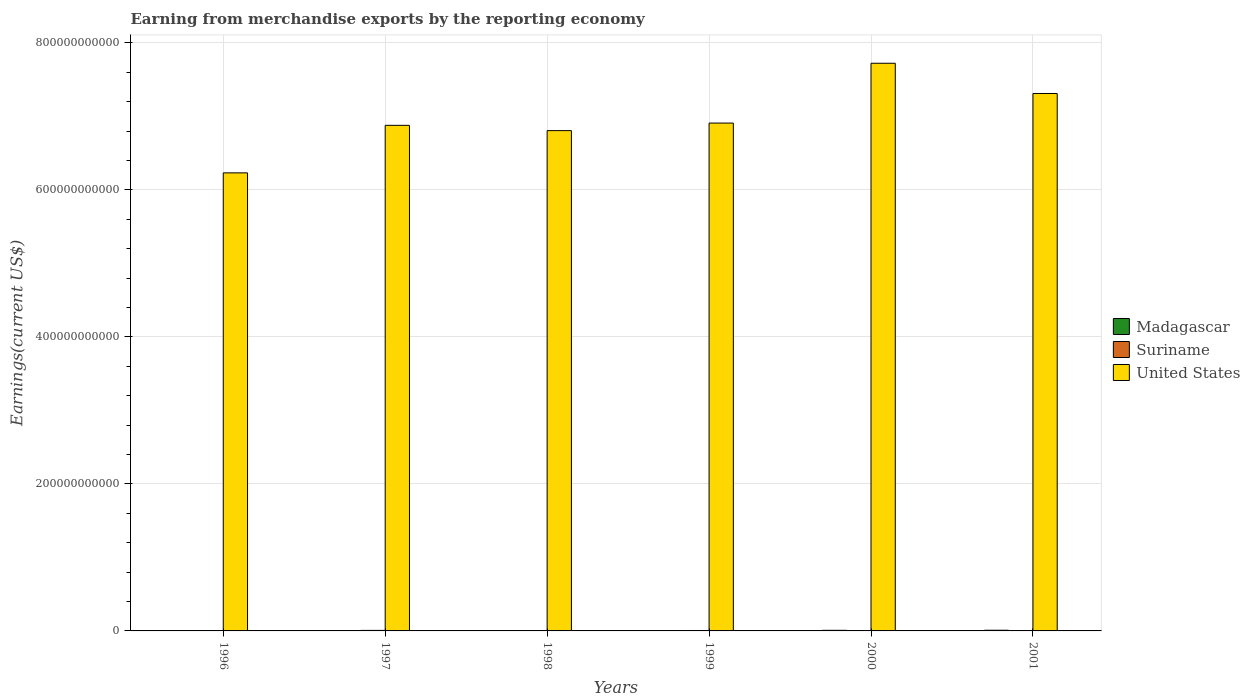How many different coloured bars are there?
Give a very brief answer. 3. How many groups of bars are there?
Offer a very short reply. 6. Are the number of bars per tick equal to the number of legend labels?
Your response must be concise. Yes. Are the number of bars on each tick of the X-axis equal?
Offer a very short reply. Yes. How many bars are there on the 5th tick from the left?
Provide a succinct answer. 3. How many bars are there on the 5th tick from the right?
Your answer should be compact. 3. What is the label of the 5th group of bars from the left?
Provide a short and direct response. 2000. What is the amount earned from merchandise exports in Suriname in 1997?
Ensure brevity in your answer.  7.01e+08. Across all years, what is the maximum amount earned from merchandise exports in Suriname?
Offer a very short reply. 7.01e+08. Across all years, what is the minimum amount earned from merchandise exports in Suriname?
Ensure brevity in your answer.  1.71e+08. In which year was the amount earned from merchandise exports in Suriname minimum?
Offer a terse response. 2001. What is the total amount earned from merchandise exports in United States in the graph?
Offer a terse response. 4.19e+12. What is the difference between the amount earned from merchandise exports in United States in 1998 and that in 1999?
Provide a succinct answer. -1.03e+1. What is the difference between the amount earned from merchandise exports in Suriname in 2001 and the amount earned from merchandise exports in United States in 1999?
Your answer should be very brief. -6.91e+11. What is the average amount earned from merchandise exports in Suriname per year?
Keep it short and to the point. 4.72e+08. In the year 2001, what is the difference between the amount earned from merchandise exports in Madagascar and amount earned from merchandise exports in United States?
Provide a short and direct response. -7.30e+11. In how many years, is the amount earned from merchandise exports in Madagascar greater than 40000000000 US$?
Offer a very short reply. 0. What is the ratio of the amount earned from merchandise exports in Suriname in 1996 to that in 1997?
Keep it short and to the point. 0.63. Is the amount earned from merchandise exports in Madagascar in 1997 less than that in 2000?
Your answer should be very brief. Yes. What is the difference between the highest and the second highest amount earned from merchandise exports in United States?
Keep it short and to the point. 4.11e+1. What is the difference between the highest and the lowest amount earned from merchandise exports in United States?
Provide a short and direct response. 1.49e+11. Is the sum of the amount earned from merchandise exports in United States in 1997 and 2000 greater than the maximum amount earned from merchandise exports in Suriname across all years?
Keep it short and to the point. Yes. What does the 2nd bar from the left in 1999 represents?
Provide a short and direct response. Suriname. What does the 3rd bar from the right in 2000 represents?
Give a very brief answer. Madagascar. Is it the case that in every year, the sum of the amount earned from merchandise exports in United States and amount earned from merchandise exports in Madagascar is greater than the amount earned from merchandise exports in Suriname?
Provide a short and direct response. Yes. Are all the bars in the graph horizontal?
Ensure brevity in your answer.  No. How many years are there in the graph?
Your answer should be compact. 6. What is the difference between two consecutive major ticks on the Y-axis?
Your response must be concise. 2.00e+11. Does the graph contain grids?
Ensure brevity in your answer.  Yes. Where does the legend appear in the graph?
Make the answer very short. Center right. What is the title of the graph?
Ensure brevity in your answer.  Earning from merchandise exports by the reporting economy. Does "El Salvador" appear as one of the legend labels in the graph?
Offer a very short reply. No. What is the label or title of the X-axis?
Your answer should be very brief. Years. What is the label or title of the Y-axis?
Offer a very short reply. Earnings(current US$). What is the Earnings(current US$) of Madagascar in 1996?
Your response must be concise. 2.99e+08. What is the Earnings(current US$) in Suriname in 1996?
Provide a short and direct response. 4.39e+08. What is the Earnings(current US$) of United States in 1996?
Give a very brief answer. 6.23e+11. What is the Earnings(current US$) in Madagascar in 1997?
Your answer should be compact. 2.24e+08. What is the Earnings(current US$) in Suriname in 1997?
Give a very brief answer. 7.01e+08. What is the Earnings(current US$) of United States in 1997?
Offer a very short reply. 6.88e+11. What is the Earnings(current US$) in Madagascar in 1998?
Your answer should be very brief. 2.34e+08. What is the Earnings(current US$) of Suriname in 1998?
Keep it short and to the point. 4.36e+08. What is the Earnings(current US$) in United States in 1998?
Your response must be concise. 6.81e+11. What is the Earnings(current US$) of Madagascar in 1999?
Provide a succinct answer. 2.20e+08. What is the Earnings(current US$) of Suriname in 1999?
Offer a terse response. 5.87e+08. What is the Earnings(current US$) in United States in 1999?
Ensure brevity in your answer.  6.91e+11. What is the Earnings(current US$) of Madagascar in 2000?
Make the answer very short. 8.24e+08. What is the Earnings(current US$) in Suriname in 2000?
Provide a succinct answer. 4.98e+08. What is the Earnings(current US$) of United States in 2000?
Your answer should be very brief. 7.72e+11. What is the Earnings(current US$) in Madagascar in 2001?
Provide a succinct answer. 9.26e+08. What is the Earnings(current US$) of Suriname in 2001?
Ensure brevity in your answer.  1.71e+08. What is the Earnings(current US$) of United States in 2001?
Your response must be concise. 7.31e+11. Across all years, what is the maximum Earnings(current US$) in Madagascar?
Your answer should be very brief. 9.26e+08. Across all years, what is the maximum Earnings(current US$) of Suriname?
Make the answer very short. 7.01e+08. Across all years, what is the maximum Earnings(current US$) in United States?
Your answer should be very brief. 7.72e+11. Across all years, what is the minimum Earnings(current US$) in Madagascar?
Make the answer very short. 2.20e+08. Across all years, what is the minimum Earnings(current US$) in Suriname?
Offer a very short reply. 1.71e+08. Across all years, what is the minimum Earnings(current US$) of United States?
Keep it short and to the point. 6.23e+11. What is the total Earnings(current US$) in Madagascar in the graph?
Ensure brevity in your answer.  2.73e+09. What is the total Earnings(current US$) of Suriname in the graph?
Your answer should be very brief. 2.83e+09. What is the total Earnings(current US$) of United States in the graph?
Your answer should be very brief. 4.19e+12. What is the difference between the Earnings(current US$) in Madagascar in 1996 and that in 1997?
Offer a terse response. 7.57e+07. What is the difference between the Earnings(current US$) in Suriname in 1996 and that in 1997?
Provide a short and direct response. -2.62e+08. What is the difference between the Earnings(current US$) in United States in 1996 and that in 1997?
Keep it short and to the point. -6.46e+1. What is the difference between the Earnings(current US$) in Madagascar in 1996 and that in 1998?
Offer a very short reply. 6.54e+07. What is the difference between the Earnings(current US$) in Suriname in 1996 and that in 1998?
Give a very brief answer. 2.89e+06. What is the difference between the Earnings(current US$) in United States in 1996 and that in 1998?
Make the answer very short. -5.75e+1. What is the difference between the Earnings(current US$) in Madagascar in 1996 and that in 1999?
Offer a very short reply. 7.90e+07. What is the difference between the Earnings(current US$) in Suriname in 1996 and that in 1999?
Offer a very short reply. -1.48e+08. What is the difference between the Earnings(current US$) in United States in 1996 and that in 1999?
Your answer should be compact. -6.77e+1. What is the difference between the Earnings(current US$) in Madagascar in 1996 and that in 2000?
Offer a terse response. -5.25e+08. What is the difference between the Earnings(current US$) of Suriname in 1996 and that in 2000?
Your answer should be compact. -5.95e+07. What is the difference between the Earnings(current US$) in United States in 1996 and that in 2000?
Give a very brief answer. -1.49e+11. What is the difference between the Earnings(current US$) of Madagascar in 1996 and that in 2001?
Give a very brief answer. -6.26e+08. What is the difference between the Earnings(current US$) in Suriname in 1996 and that in 2001?
Your response must be concise. 2.68e+08. What is the difference between the Earnings(current US$) of United States in 1996 and that in 2001?
Provide a succinct answer. -1.08e+11. What is the difference between the Earnings(current US$) of Madagascar in 1997 and that in 1998?
Provide a short and direct response. -1.03e+07. What is the difference between the Earnings(current US$) in Suriname in 1997 and that in 1998?
Provide a short and direct response. 2.65e+08. What is the difference between the Earnings(current US$) of United States in 1997 and that in 1998?
Your answer should be very brief. 7.19e+09. What is the difference between the Earnings(current US$) in Madagascar in 1997 and that in 1999?
Offer a terse response. 3.26e+06. What is the difference between the Earnings(current US$) of Suriname in 1997 and that in 1999?
Provide a succinct answer. 1.15e+08. What is the difference between the Earnings(current US$) in United States in 1997 and that in 1999?
Provide a short and direct response. -3.08e+09. What is the difference between the Earnings(current US$) in Madagascar in 1997 and that in 2000?
Keep it short and to the point. -6.00e+08. What is the difference between the Earnings(current US$) in Suriname in 1997 and that in 2000?
Offer a very short reply. 2.03e+08. What is the difference between the Earnings(current US$) in United States in 1997 and that in 2000?
Your answer should be very brief. -8.44e+1. What is the difference between the Earnings(current US$) of Madagascar in 1997 and that in 2001?
Provide a succinct answer. -7.02e+08. What is the difference between the Earnings(current US$) of Suriname in 1997 and that in 2001?
Keep it short and to the point. 5.30e+08. What is the difference between the Earnings(current US$) of United States in 1997 and that in 2001?
Provide a succinct answer. -4.33e+1. What is the difference between the Earnings(current US$) of Madagascar in 1998 and that in 1999?
Keep it short and to the point. 1.36e+07. What is the difference between the Earnings(current US$) of Suriname in 1998 and that in 1999?
Your answer should be very brief. -1.51e+08. What is the difference between the Earnings(current US$) of United States in 1998 and that in 1999?
Give a very brief answer. -1.03e+1. What is the difference between the Earnings(current US$) in Madagascar in 1998 and that in 2000?
Make the answer very short. -5.90e+08. What is the difference between the Earnings(current US$) of Suriname in 1998 and that in 2000?
Your answer should be very brief. -6.24e+07. What is the difference between the Earnings(current US$) in United States in 1998 and that in 2000?
Provide a short and direct response. -9.16e+1. What is the difference between the Earnings(current US$) in Madagascar in 1998 and that in 2001?
Give a very brief answer. -6.92e+08. What is the difference between the Earnings(current US$) of Suriname in 1998 and that in 2001?
Your answer should be compact. 2.65e+08. What is the difference between the Earnings(current US$) in United States in 1998 and that in 2001?
Your answer should be compact. -5.05e+1. What is the difference between the Earnings(current US$) in Madagascar in 1999 and that in 2000?
Your answer should be compact. -6.04e+08. What is the difference between the Earnings(current US$) in Suriname in 1999 and that in 2000?
Give a very brief answer. 8.82e+07. What is the difference between the Earnings(current US$) in United States in 1999 and that in 2000?
Give a very brief answer. -8.14e+1. What is the difference between the Earnings(current US$) of Madagascar in 1999 and that in 2001?
Offer a very short reply. -7.05e+08. What is the difference between the Earnings(current US$) in Suriname in 1999 and that in 2001?
Your response must be concise. 4.16e+08. What is the difference between the Earnings(current US$) of United States in 1999 and that in 2001?
Offer a very short reply. -4.02e+1. What is the difference between the Earnings(current US$) of Madagascar in 2000 and that in 2001?
Keep it short and to the point. -1.02e+08. What is the difference between the Earnings(current US$) of Suriname in 2000 and that in 2001?
Provide a succinct answer. 3.27e+08. What is the difference between the Earnings(current US$) of United States in 2000 and that in 2001?
Ensure brevity in your answer.  4.11e+1. What is the difference between the Earnings(current US$) of Madagascar in 1996 and the Earnings(current US$) of Suriname in 1997?
Offer a very short reply. -4.02e+08. What is the difference between the Earnings(current US$) of Madagascar in 1996 and the Earnings(current US$) of United States in 1997?
Offer a terse response. -6.87e+11. What is the difference between the Earnings(current US$) in Suriname in 1996 and the Earnings(current US$) in United States in 1997?
Provide a short and direct response. -6.87e+11. What is the difference between the Earnings(current US$) in Madagascar in 1996 and the Earnings(current US$) in Suriname in 1998?
Your answer should be compact. -1.37e+08. What is the difference between the Earnings(current US$) of Madagascar in 1996 and the Earnings(current US$) of United States in 1998?
Make the answer very short. -6.80e+11. What is the difference between the Earnings(current US$) in Suriname in 1996 and the Earnings(current US$) in United States in 1998?
Provide a short and direct response. -6.80e+11. What is the difference between the Earnings(current US$) in Madagascar in 1996 and the Earnings(current US$) in Suriname in 1999?
Give a very brief answer. -2.87e+08. What is the difference between the Earnings(current US$) in Madagascar in 1996 and the Earnings(current US$) in United States in 1999?
Make the answer very short. -6.90e+11. What is the difference between the Earnings(current US$) in Suriname in 1996 and the Earnings(current US$) in United States in 1999?
Offer a very short reply. -6.90e+11. What is the difference between the Earnings(current US$) in Madagascar in 1996 and the Earnings(current US$) in Suriname in 2000?
Offer a very short reply. -1.99e+08. What is the difference between the Earnings(current US$) in Madagascar in 1996 and the Earnings(current US$) in United States in 2000?
Offer a very short reply. -7.72e+11. What is the difference between the Earnings(current US$) of Suriname in 1996 and the Earnings(current US$) of United States in 2000?
Ensure brevity in your answer.  -7.72e+11. What is the difference between the Earnings(current US$) of Madagascar in 1996 and the Earnings(current US$) of Suriname in 2001?
Ensure brevity in your answer.  1.28e+08. What is the difference between the Earnings(current US$) in Madagascar in 1996 and the Earnings(current US$) in United States in 2001?
Make the answer very short. -7.31e+11. What is the difference between the Earnings(current US$) in Suriname in 1996 and the Earnings(current US$) in United States in 2001?
Keep it short and to the point. -7.31e+11. What is the difference between the Earnings(current US$) of Madagascar in 1997 and the Earnings(current US$) of Suriname in 1998?
Your response must be concise. -2.12e+08. What is the difference between the Earnings(current US$) of Madagascar in 1997 and the Earnings(current US$) of United States in 1998?
Keep it short and to the point. -6.80e+11. What is the difference between the Earnings(current US$) of Suriname in 1997 and the Earnings(current US$) of United States in 1998?
Offer a very short reply. -6.80e+11. What is the difference between the Earnings(current US$) in Madagascar in 1997 and the Earnings(current US$) in Suriname in 1999?
Provide a short and direct response. -3.63e+08. What is the difference between the Earnings(current US$) in Madagascar in 1997 and the Earnings(current US$) in United States in 1999?
Offer a very short reply. -6.91e+11. What is the difference between the Earnings(current US$) in Suriname in 1997 and the Earnings(current US$) in United States in 1999?
Provide a succinct answer. -6.90e+11. What is the difference between the Earnings(current US$) of Madagascar in 1997 and the Earnings(current US$) of Suriname in 2000?
Offer a very short reply. -2.75e+08. What is the difference between the Earnings(current US$) of Madagascar in 1997 and the Earnings(current US$) of United States in 2000?
Keep it short and to the point. -7.72e+11. What is the difference between the Earnings(current US$) in Suriname in 1997 and the Earnings(current US$) in United States in 2000?
Ensure brevity in your answer.  -7.71e+11. What is the difference between the Earnings(current US$) in Madagascar in 1997 and the Earnings(current US$) in Suriname in 2001?
Make the answer very short. 5.26e+07. What is the difference between the Earnings(current US$) of Madagascar in 1997 and the Earnings(current US$) of United States in 2001?
Make the answer very short. -7.31e+11. What is the difference between the Earnings(current US$) of Suriname in 1997 and the Earnings(current US$) of United States in 2001?
Offer a terse response. -7.30e+11. What is the difference between the Earnings(current US$) in Madagascar in 1998 and the Earnings(current US$) in Suriname in 1999?
Your answer should be very brief. -3.53e+08. What is the difference between the Earnings(current US$) in Madagascar in 1998 and the Earnings(current US$) in United States in 1999?
Keep it short and to the point. -6.91e+11. What is the difference between the Earnings(current US$) of Suriname in 1998 and the Earnings(current US$) of United States in 1999?
Your answer should be very brief. -6.90e+11. What is the difference between the Earnings(current US$) of Madagascar in 1998 and the Earnings(current US$) of Suriname in 2000?
Provide a succinct answer. -2.64e+08. What is the difference between the Earnings(current US$) of Madagascar in 1998 and the Earnings(current US$) of United States in 2000?
Provide a succinct answer. -7.72e+11. What is the difference between the Earnings(current US$) of Suriname in 1998 and the Earnings(current US$) of United States in 2000?
Provide a succinct answer. -7.72e+11. What is the difference between the Earnings(current US$) in Madagascar in 1998 and the Earnings(current US$) in Suriname in 2001?
Make the answer very short. 6.30e+07. What is the difference between the Earnings(current US$) in Madagascar in 1998 and the Earnings(current US$) in United States in 2001?
Your response must be concise. -7.31e+11. What is the difference between the Earnings(current US$) in Suriname in 1998 and the Earnings(current US$) in United States in 2001?
Your answer should be compact. -7.31e+11. What is the difference between the Earnings(current US$) in Madagascar in 1999 and the Earnings(current US$) in Suriname in 2000?
Ensure brevity in your answer.  -2.78e+08. What is the difference between the Earnings(current US$) of Madagascar in 1999 and the Earnings(current US$) of United States in 2000?
Your response must be concise. -7.72e+11. What is the difference between the Earnings(current US$) in Suriname in 1999 and the Earnings(current US$) in United States in 2000?
Provide a short and direct response. -7.72e+11. What is the difference between the Earnings(current US$) in Madagascar in 1999 and the Earnings(current US$) in Suriname in 2001?
Provide a short and direct response. 4.94e+07. What is the difference between the Earnings(current US$) of Madagascar in 1999 and the Earnings(current US$) of United States in 2001?
Ensure brevity in your answer.  -7.31e+11. What is the difference between the Earnings(current US$) in Suriname in 1999 and the Earnings(current US$) in United States in 2001?
Keep it short and to the point. -7.30e+11. What is the difference between the Earnings(current US$) of Madagascar in 2000 and the Earnings(current US$) of Suriname in 2001?
Keep it short and to the point. 6.53e+08. What is the difference between the Earnings(current US$) in Madagascar in 2000 and the Earnings(current US$) in United States in 2001?
Offer a terse response. -7.30e+11. What is the difference between the Earnings(current US$) of Suriname in 2000 and the Earnings(current US$) of United States in 2001?
Offer a very short reply. -7.31e+11. What is the average Earnings(current US$) in Madagascar per year?
Make the answer very short. 4.55e+08. What is the average Earnings(current US$) of Suriname per year?
Your response must be concise. 4.72e+08. What is the average Earnings(current US$) of United States per year?
Provide a short and direct response. 6.98e+11. In the year 1996, what is the difference between the Earnings(current US$) of Madagascar and Earnings(current US$) of Suriname?
Keep it short and to the point. -1.39e+08. In the year 1996, what is the difference between the Earnings(current US$) in Madagascar and Earnings(current US$) in United States?
Give a very brief answer. -6.23e+11. In the year 1996, what is the difference between the Earnings(current US$) in Suriname and Earnings(current US$) in United States?
Your answer should be compact. -6.23e+11. In the year 1997, what is the difference between the Earnings(current US$) in Madagascar and Earnings(current US$) in Suriname?
Provide a short and direct response. -4.78e+08. In the year 1997, what is the difference between the Earnings(current US$) of Madagascar and Earnings(current US$) of United States?
Provide a succinct answer. -6.87e+11. In the year 1997, what is the difference between the Earnings(current US$) in Suriname and Earnings(current US$) in United States?
Offer a terse response. -6.87e+11. In the year 1998, what is the difference between the Earnings(current US$) of Madagascar and Earnings(current US$) of Suriname?
Provide a short and direct response. -2.02e+08. In the year 1998, what is the difference between the Earnings(current US$) of Madagascar and Earnings(current US$) of United States?
Your answer should be compact. -6.80e+11. In the year 1998, what is the difference between the Earnings(current US$) of Suriname and Earnings(current US$) of United States?
Offer a terse response. -6.80e+11. In the year 1999, what is the difference between the Earnings(current US$) in Madagascar and Earnings(current US$) in Suriname?
Your answer should be very brief. -3.66e+08. In the year 1999, what is the difference between the Earnings(current US$) in Madagascar and Earnings(current US$) in United States?
Offer a very short reply. -6.91e+11. In the year 1999, what is the difference between the Earnings(current US$) of Suriname and Earnings(current US$) of United States?
Ensure brevity in your answer.  -6.90e+11. In the year 2000, what is the difference between the Earnings(current US$) of Madagascar and Earnings(current US$) of Suriname?
Your answer should be very brief. 3.26e+08. In the year 2000, what is the difference between the Earnings(current US$) in Madagascar and Earnings(current US$) in United States?
Give a very brief answer. -7.71e+11. In the year 2000, what is the difference between the Earnings(current US$) of Suriname and Earnings(current US$) of United States?
Offer a very short reply. -7.72e+11. In the year 2001, what is the difference between the Earnings(current US$) in Madagascar and Earnings(current US$) in Suriname?
Offer a very short reply. 7.55e+08. In the year 2001, what is the difference between the Earnings(current US$) in Madagascar and Earnings(current US$) in United States?
Offer a terse response. -7.30e+11. In the year 2001, what is the difference between the Earnings(current US$) in Suriname and Earnings(current US$) in United States?
Your answer should be compact. -7.31e+11. What is the ratio of the Earnings(current US$) in Madagascar in 1996 to that in 1997?
Your response must be concise. 1.34. What is the ratio of the Earnings(current US$) in Suriname in 1996 to that in 1997?
Provide a short and direct response. 0.63. What is the ratio of the Earnings(current US$) in United States in 1996 to that in 1997?
Your answer should be compact. 0.91. What is the ratio of the Earnings(current US$) of Madagascar in 1996 to that in 1998?
Provide a short and direct response. 1.28. What is the ratio of the Earnings(current US$) in Suriname in 1996 to that in 1998?
Your response must be concise. 1.01. What is the ratio of the Earnings(current US$) in United States in 1996 to that in 1998?
Provide a succinct answer. 0.92. What is the ratio of the Earnings(current US$) in Madagascar in 1996 to that in 1999?
Keep it short and to the point. 1.36. What is the ratio of the Earnings(current US$) of Suriname in 1996 to that in 1999?
Provide a short and direct response. 0.75. What is the ratio of the Earnings(current US$) in United States in 1996 to that in 1999?
Ensure brevity in your answer.  0.9. What is the ratio of the Earnings(current US$) in Madagascar in 1996 to that in 2000?
Ensure brevity in your answer.  0.36. What is the ratio of the Earnings(current US$) in Suriname in 1996 to that in 2000?
Offer a terse response. 0.88. What is the ratio of the Earnings(current US$) of United States in 1996 to that in 2000?
Your response must be concise. 0.81. What is the ratio of the Earnings(current US$) of Madagascar in 1996 to that in 2001?
Your response must be concise. 0.32. What is the ratio of the Earnings(current US$) of Suriname in 1996 to that in 2001?
Your answer should be compact. 2.56. What is the ratio of the Earnings(current US$) of United States in 1996 to that in 2001?
Provide a succinct answer. 0.85. What is the ratio of the Earnings(current US$) in Madagascar in 1997 to that in 1998?
Ensure brevity in your answer.  0.96. What is the ratio of the Earnings(current US$) of Suriname in 1997 to that in 1998?
Provide a succinct answer. 1.61. What is the ratio of the Earnings(current US$) of United States in 1997 to that in 1998?
Provide a succinct answer. 1.01. What is the ratio of the Earnings(current US$) of Madagascar in 1997 to that in 1999?
Give a very brief answer. 1.01. What is the ratio of the Earnings(current US$) in Suriname in 1997 to that in 1999?
Your response must be concise. 1.2. What is the ratio of the Earnings(current US$) of Madagascar in 1997 to that in 2000?
Provide a succinct answer. 0.27. What is the ratio of the Earnings(current US$) of Suriname in 1997 to that in 2000?
Your answer should be compact. 1.41. What is the ratio of the Earnings(current US$) in United States in 1997 to that in 2000?
Make the answer very short. 0.89. What is the ratio of the Earnings(current US$) of Madagascar in 1997 to that in 2001?
Offer a very short reply. 0.24. What is the ratio of the Earnings(current US$) of Suriname in 1997 to that in 2001?
Give a very brief answer. 4.1. What is the ratio of the Earnings(current US$) of United States in 1997 to that in 2001?
Give a very brief answer. 0.94. What is the ratio of the Earnings(current US$) of Madagascar in 1998 to that in 1999?
Make the answer very short. 1.06. What is the ratio of the Earnings(current US$) of Suriname in 1998 to that in 1999?
Your answer should be very brief. 0.74. What is the ratio of the Earnings(current US$) of United States in 1998 to that in 1999?
Your response must be concise. 0.99. What is the ratio of the Earnings(current US$) of Madagascar in 1998 to that in 2000?
Your answer should be compact. 0.28. What is the ratio of the Earnings(current US$) of Suriname in 1998 to that in 2000?
Your answer should be very brief. 0.87. What is the ratio of the Earnings(current US$) of United States in 1998 to that in 2000?
Give a very brief answer. 0.88. What is the ratio of the Earnings(current US$) in Madagascar in 1998 to that in 2001?
Provide a short and direct response. 0.25. What is the ratio of the Earnings(current US$) of Suriname in 1998 to that in 2001?
Make the answer very short. 2.55. What is the ratio of the Earnings(current US$) in United States in 1998 to that in 2001?
Provide a succinct answer. 0.93. What is the ratio of the Earnings(current US$) of Madagascar in 1999 to that in 2000?
Make the answer very short. 0.27. What is the ratio of the Earnings(current US$) in Suriname in 1999 to that in 2000?
Your answer should be very brief. 1.18. What is the ratio of the Earnings(current US$) of United States in 1999 to that in 2000?
Your answer should be compact. 0.89. What is the ratio of the Earnings(current US$) in Madagascar in 1999 to that in 2001?
Your answer should be very brief. 0.24. What is the ratio of the Earnings(current US$) of Suriname in 1999 to that in 2001?
Your answer should be compact. 3.43. What is the ratio of the Earnings(current US$) in United States in 1999 to that in 2001?
Your response must be concise. 0.94. What is the ratio of the Earnings(current US$) in Madagascar in 2000 to that in 2001?
Provide a short and direct response. 0.89. What is the ratio of the Earnings(current US$) in Suriname in 2000 to that in 2001?
Provide a succinct answer. 2.91. What is the ratio of the Earnings(current US$) of United States in 2000 to that in 2001?
Your answer should be very brief. 1.06. What is the difference between the highest and the second highest Earnings(current US$) in Madagascar?
Provide a short and direct response. 1.02e+08. What is the difference between the highest and the second highest Earnings(current US$) of Suriname?
Keep it short and to the point. 1.15e+08. What is the difference between the highest and the second highest Earnings(current US$) of United States?
Offer a very short reply. 4.11e+1. What is the difference between the highest and the lowest Earnings(current US$) in Madagascar?
Your response must be concise. 7.05e+08. What is the difference between the highest and the lowest Earnings(current US$) of Suriname?
Ensure brevity in your answer.  5.30e+08. What is the difference between the highest and the lowest Earnings(current US$) in United States?
Your answer should be compact. 1.49e+11. 